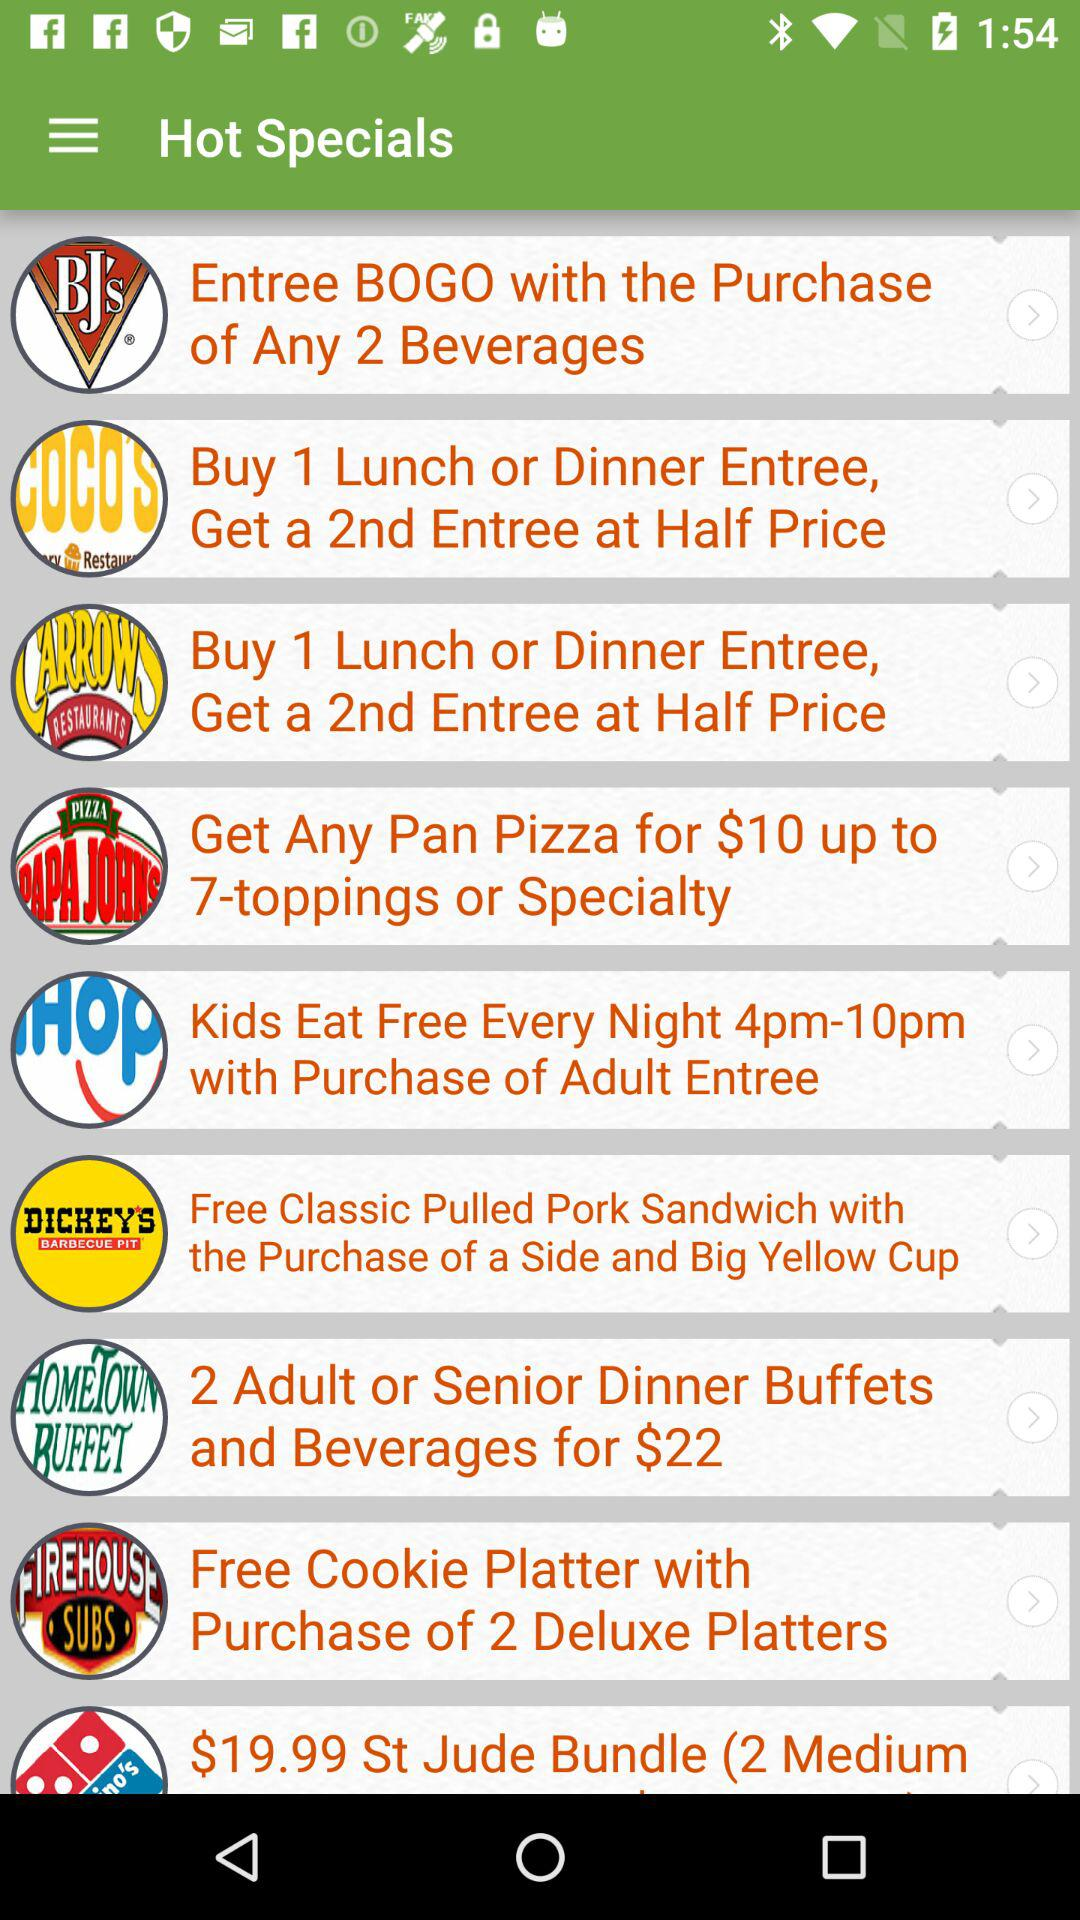With the purchase of which platter can we get a free cookie platter? With the purchase of 2 deluxe platters, you can get a free cookie platter. 